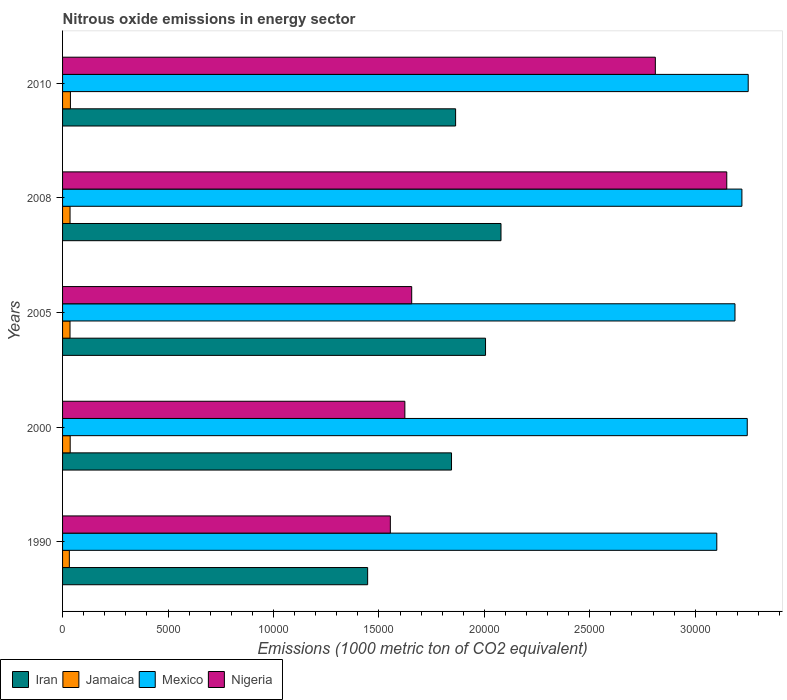How many different coloured bars are there?
Your answer should be compact. 4. In how many cases, is the number of bars for a given year not equal to the number of legend labels?
Give a very brief answer. 0. What is the amount of nitrous oxide emitted in Jamaica in 2000?
Ensure brevity in your answer.  361.6. Across all years, what is the maximum amount of nitrous oxide emitted in Nigeria?
Your answer should be compact. 3.15e+04. Across all years, what is the minimum amount of nitrous oxide emitted in Jamaica?
Give a very brief answer. 321.7. In which year was the amount of nitrous oxide emitted in Jamaica maximum?
Keep it short and to the point. 2010. What is the total amount of nitrous oxide emitted in Iran in the graph?
Give a very brief answer. 9.24e+04. What is the difference between the amount of nitrous oxide emitted in Nigeria in 2005 and that in 2008?
Provide a succinct answer. -1.49e+04. What is the difference between the amount of nitrous oxide emitted in Mexico in 1990 and the amount of nitrous oxide emitted in Nigeria in 2010?
Provide a short and direct response. 2914.6. What is the average amount of nitrous oxide emitted in Jamaica per year?
Your answer should be compact. 352.82. In the year 2008, what is the difference between the amount of nitrous oxide emitted in Mexico and amount of nitrous oxide emitted in Nigeria?
Your answer should be compact. 718.4. What is the ratio of the amount of nitrous oxide emitted in Jamaica in 2000 to that in 2010?
Your answer should be very brief. 0.97. Is the amount of nitrous oxide emitted in Jamaica in 2000 less than that in 2010?
Your response must be concise. Yes. Is the difference between the amount of nitrous oxide emitted in Mexico in 2005 and 2010 greater than the difference between the amount of nitrous oxide emitted in Nigeria in 2005 and 2010?
Give a very brief answer. Yes. What is the difference between the highest and the second highest amount of nitrous oxide emitted in Mexico?
Offer a terse response. 45.2. What is the difference between the highest and the lowest amount of nitrous oxide emitted in Mexico?
Provide a short and direct response. 1489.2. In how many years, is the amount of nitrous oxide emitted in Mexico greater than the average amount of nitrous oxide emitted in Mexico taken over all years?
Provide a succinct answer. 3. What does the 3rd bar from the top in 2008 represents?
Ensure brevity in your answer.  Jamaica. What does the 1st bar from the bottom in 2008 represents?
Your answer should be compact. Iran. What is the difference between two consecutive major ticks on the X-axis?
Offer a very short reply. 5000. Are the values on the major ticks of X-axis written in scientific E-notation?
Give a very brief answer. No. Does the graph contain grids?
Keep it short and to the point. No. How many legend labels are there?
Give a very brief answer. 4. How are the legend labels stacked?
Make the answer very short. Horizontal. What is the title of the graph?
Give a very brief answer. Nitrous oxide emissions in energy sector. Does "World" appear as one of the legend labels in the graph?
Make the answer very short. No. What is the label or title of the X-axis?
Your response must be concise. Emissions (1000 metric ton of CO2 equivalent). What is the Emissions (1000 metric ton of CO2 equivalent) of Iran in 1990?
Ensure brevity in your answer.  1.45e+04. What is the Emissions (1000 metric ton of CO2 equivalent) of Jamaica in 1990?
Make the answer very short. 321.7. What is the Emissions (1000 metric ton of CO2 equivalent) of Mexico in 1990?
Your response must be concise. 3.10e+04. What is the Emissions (1000 metric ton of CO2 equivalent) of Nigeria in 1990?
Provide a short and direct response. 1.55e+04. What is the Emissions (1000 metric ton of CO2 equivalent) in Iran in 2000?
Offer a very short reply. 1.84e+04. What is the Emissions (1000 metric ton of CO2 equivalent) of Jamaica in 2000?
Offer a terse response. 361.6. What is the Emissions (1000 metric ton of CO2 equivalent) in Mexico in 2000?
Offer a very short reply. 3.25e+04. What is the Emissions (1000 metric ton of CO2 equivalent) in Nigeria in 2000?
Ensure brevity in your answer.  1.62e+04. What is the Emissions (1000 metric ton of CO2 equivalent) in Iran in 2005?
Your response must be concise. 2.01e+04. What is the Emissions (1000 metric ton of CO2 equivalent) of Jamaica in 2005?
Your answer should be compact. 353.5. What is the Emissions (1000 metric ton of CO2 equivalent) of Mexico in 2005?
Keep it short and to the point. 3.19e+04. What is the Emissions (1000 metric ton of CO2 equivalent) in Nigeria in 2005?
Provide a short and direct response. 1.66e+04. What is the Emissions (1000 metric ton of CO2 equivalent) in Iran in 2008?
Provide a short and direct response. 2.08e+04. What is the Emissions (1000 metric ton of CO2 equivalent) of Jamaica in 2008?
Keep it short and to the point. 354.8. What is the Emissions (1000 metric ton of CO2 equivalent) in Mexico in 2008?
Offer a terse response. 3.22e+04. What is the Emissions (1000 metric ton of CO2 equivalent) in Nigeria in 2008?
Keep it short and to the point. 3.15e+04. What is the Emissions (1000 metric ton of CO2 equivalent) in Iran in 2010?
Your answer should be very brief. 1.86e+04. What is the Emissions (1000 metric ton of CO2 equivalent) in Jamaica in 2010?
Your answer should be very brief. 372.5. What is the Emissions (1000 metric ton of CO2 equivalent) in Mexico in 2010?
Offer a terse response. 3.25e+04. What is the Emissions (1000 metric ton of CO2 equivalent) in Nigeria in 2010?
Give a very brief answer. 2.81e+04. Across all years, what is the maximum Emissions (1000 metric ton of CO2 equivalent) of Iran?
Your answer should be very brief. 2.08e+04. Across all years, what is the maximum Emissions (1000 metric ton of CO2 equivalent) of Jamaica?
Make the answer very short. 372.5. Across all years, what is the maximum Emissions (1000 metric ton of CO2 equivalent) of Mexico?
Ensure brevity in your answer.  3.25e+04. Across all years, what is the maximum Emissions (1000 metric ton of CO2 equivalent) in Nigeria?
Provide a succinct answer. 3.15e+04. Across all years, what is the minimum Emissions (1000 metric ton of CO2 equivalent) of Iran?
Ensure brevity in your answer.  1.45e+04. Across all years, what is the minimum Emissions (1000 metric ton of CO2 equivalent) in Jamaica?
Give a very brief answer. 321.7. Across all years, what is the minimum Emissions (1000 metric ton of CO2 equivalent) of Mexico?
Provide a short and direct response. 3.10e+04. Across all years, what is the minimum Emissions (1000 metric ton of CO2 equivalent) in Nigeria?
Ensure brevity in your answer.  1.55e+04. What is the total Emissions (1000 metric ton of CO2 equivalent) in Iran in the graph?
Offer a very short reply. 9.24e+04. What is the total Emissions (1000 metric ton of CO2 equivalent) of Jamaica in the graph?
Offer a terse response. 1764.1. What is the total Emissions (1000 metric ton of CO2 equivalent) in Mexico in the graph?
Give a very brief answer. 1.60e+05. What is the total Emissions (1000 metric ton of CO2 equivalent) in Nigeria in the graph?
Ensure brevity in your answer.  1.08e+05. What is the difference between the Emissions (1000 metric ton of CO2 equivalent) of Iran in 1990 and that in 2000?
Provide a short and direct response. -3977.6. What is the difference between the Emissions (1000 metric ton of CO2 equivalent) in Jamaica in 1990 and that in 2000?
Your answer should be very brief. -39.9. What is the difference between the Emissions (1000 metric ton of CO2 equivalent) in Mexico in 1990 and that in 2000?
Offer a terse response. -1444. What is the difference between the Emissions (1000 metric ton of CO2 equivalent) in Nigeria in 1990 and that in 2000?
Keep it short and to the point. -688.1. What is the difference between the Emissions (1000 metric ton of CO2 equivalent) of Iran in 1990 and that in 2005?
Provide a short and direct response. -5590.3. What is the difference between the Emissions (1000 metric ton of CO2 equivalent) in Jamaica in 1990 and that in 2005?
Your answer should be compact. -31.8. What is the difference between the Emissions (1000 metric ton of CO2 equivalent) of Mexico in 1990 and that in 2005?
Give a very brief answer. -862.3. What is the difference between the Emissions (1000 metric ton of CO2 equivalent) in Nigeria in 1990 and that in 2005?
Your answer should be very brief. -1013. What is the difference between the Emissions (1000 metric ton of CO2 equivalent) of Iran in 1990 and that in 2008?
Give a very brief answer. -6323.6. What is the difference between the Emissions (1000 metric ton of CO2 equivalent) of Jamaica in 1990 and that in 2008?
Make the answer very short. -33.1. What is the difference between the Emissions (1000 metric ton of CO2 equivalent) of Mexico in 1990 and that in 2008?
Offer a terse response. -1190.5. What is the difference between the Emissions (1000 metric ton of CO2 equivalent) in Nigeria in 1990 and that in 2008?
Ensure brevity in your answer.  -1.60e+04. What is the difference between the Emissions (1000 metric ton of CO2 equivalent) in Iran in 1990 and that in 2010?
Offer a very short reply. -4171.6. What is the difference between the Emissions (1000 metric ton of CO2 equivalent) of Jamaica in 1990 and that in 2010?
Ensure brevity in your answer.  -50.8. What is the difference between the Emissions (1000 metric ton of CO2 equivalent) of Mexico in 1990 and that in 2010?
Give a very brief answer. -1489.2. What is the difference between the Emissions (1000 metric ton of CO2 equivalent) of Nigeria in 1990 and that in 2010?
Ensure brevity in your answer.  -1.26e+04. What is the difference between the Emissions (1000 metric ton of CO2 equivalent) of Iran in 2000 and that in 2005?
Ensure brevity in your answer.  -1612.7. What is the difference between the Emissions (1000 metric ton of CO2 equivalent) in Jamaica in 2000 and that in 2005?
Keep it short and to the point. 8.1. What is the difference between the Emissions (1000 metric ton of CO2 equivalent) of Mexico in 2000 and that in 2005?
Make the answer very short. 581.7. What is the difference between the Emissions (1000 metric ton of CO2 equivalent) of Nigeria in 2000 and that in 2005?
Provide a short and direct response. -324.9. What is the difference between the Emissions (1000 metric ton of CO2 equivalent) of Iran in 2000 and that in 2008?
Provide a short and direct response. -2346. What is the difference between the Emissions (1000 metric ton of CO2 equivalent) of Jamaica in 2000 and that in 2008?
Provide a succinct answer. 6.8. What is the difference between the Emissions (1000 metric ton of CO2 equivalent) of Mexico in 2000 and that in 2008?
Provide a succinct answer. 253.5. What is the difference between the Emissions (1000 metric ton of CO2 equivalent) of Nigeria in 2000 and that in 2008?
Ensure brevity in your answer.  -1.53e+04. What is the difference between the Emissions (1000 metric ton of CO2 equivalent) of Iran in 2000 and that in 2010?
Give a very brief answer. -194. What is the difference between the Emissions (1000 metric ton of CO2 equivalent) of Jamaica in 2000 and that in 2010?
Provide a succinct answer. -10.9. What is the difference between the Emissions (1000 metric ton of CO2 equivalent) of Mexico in 2000 and that in 2010?
Make the answer very short. -45.2. What is the difference between the Emissions (1000 metric ton of CO2 equivalent) of Nigeria in 2000 and that in 2010?
Offer a very short reply. -1.19e+04. What is the difference between the Emissions (1000 metric ton of CO2 equivalent) of Iran in 2005 and that in 2008?
Your response must be concise. -733.3. What is the difference between the Emissions (1000 metric ton of CO2 equivalent) in Mexico in 2005 and that in 2008?
Make the answer very short. -328.2. What is the difference between the Emissions (1000 metric ton of CO2 equivalent) of Nigeria in 2005 and that in 2008?
Keep it short and to the point. -1.49e+04. What is the difference between the Emissions (1000 metric ton of CO2 equivalent) of Iran in 2005 and that in 2010?
Provide a succinct answer. 1418.7. What is the difference between the Emissions (1000 metric ton of CO2 equivalent) in Jamaica in 2005 and that in 2010?
Your answer should be compact. -19. What is the difference between the Emissions (1000 metric ton of CO2 equivalent) of Mexico in 2005 and that in 2010?
Ensure brevity in your answer.  -626.9. What is the difference between the Emissions (1000 metric ton of CO2 equivalent) of Nigeria in 2005 and that in 2010?
Provide a succinct answer. -1.16e+04. What is the difference between the Emissions (1000 metric ton of CO2 equivalent) in Iran in 2008 and that in 2010?
Your answer should be compact. 2152. What is the difference between the Emissions (1000 metric ton of CO2 equivalent) of Jamaica in 2008 and that in 2010?
Give a very brief answer. -17.7. What is the difference between the Emissions (1000 metric ton of CO2 equivalent) in Mexico in 2008 and that in 2010?
Offer a terse response. -298.7. What is the difference between the Emissions (1000 metric ton of CO2 equivalent) of Nigeria in 2008 and that in 2010?
Make the answer very short. 3386.7. What is the difference between the Emissions (1000 metric ton of CO2 equivalent) of Iran in 1990 and the Emissions (1000 metric ton of CO2 equivalent) of Jamaica in 2000?
Give a very brief answer. 1.41e+04. What is the difference between the Emissions (1000 metric ton of CO2 equivalent) in Iran in 1990 and the Emissions (1000 metric ton of CO2 equivalent) in Mexico in 2000?
Make the answer very short. -1.80e+04. What is the difference between the Emissions (1000 metric ton of CO2 equivalent) of Iran in 1990 and the Emissions (1000 metric ton of CO2 equivalent) of Nigeria in 2000?
Your answer should be compact. -1764.9. What is the difference between the Emissions (1000 metric ton of CO2 equivalent) in Jamaica in 1990 and the Emissions (1000 metric ton of CO2 equivalent) in Mexico in 2000?
Your answer should be very brief. -3.21e+04. What is the difference between the Emissions (1000 metric ton of CO2 equivalent) of Jamaica in 1990 and the Emissions (1000 metric ton of CO2 equivalent) of Nigeria in 2000?
Your answer should be very brief. -1.59e+04. What is the difference between the Emissions (1000 metric ton of CO2 equivalent) in Mexico in 1990 and the Emissions (1000 metric ton of CO2 equivalent) in Nigeria in 2000?
Make the answer very short. 1.48e+04. What is the difference between the Emissions (1000 metric ton of CO2 equivalent) in Iran in 1990 and the Emissions (1000 metric ton of CO2 equivalent) in Jamaica in 2005?
Keep it short and to the point. 1.41e+04. What is the difference between the Emissions (1000 metric ton of CO2 equivalent) in Iran in 1990 and the Emissions (1000 metric ton of CO2 equivalent) in Mexico in 2005?
Give a very brief answer. -1.74e+04. What is the difference between the Emissions (1000 metric ton of CO2 equivalent) in Iran in 1990 and the Emissions (1000 metric ton of CO2 equivalent) in Nigeria in 2005?
Your answer should be compact. -2089.8. What is the difference between the Emissions (1000 metric ton of CO2 equivalent) of Jamaica in 1990 and the Emissions (1000 metric ton of CO2 equivalent) of Mexico in 2005?
Give a very brief answer. -3.16e+04. What is the difference between the Emissions (1000 metric ton of CO2 equivalent) in Jamaica in 1990 and the Emissions (1000 metric ton of CO2 equivalent) in Nigeria in 2005?
Offer a very short reply. -1.62e+04. What is the difference between the Emissions (1000 metric ton of CO2 equivalent) in Mexico in 1990 and the Emissions (1000 metric ton of CO2 equivalent) in Nigeria in 2005?
Ensure brevity in your answer.  1.45e+04. What is the difference between the Emissions (1000 metric ton of CO2 equivalent) in Iran in 1990 and the Emissions (1000 metric ton of CO2 equivalent) in Jamaica in 2008?
Offer a very short reply. 1.41e+04. What is the difference between the Emissions (1000 metric ton of CO2 equivalent) of Iran in 1990 and the Emissions (1000 metric ton of CO2 equivalent) of Mexico in 2008?
Your answer should be very brief. -1.77e+04. What is the difference between the Emissions (1000 metric ton of CO2 equivalent) of Iran in 1990 and the Emissions (1000 metric ton of CO2 equivalent) of Nigeria in 2008?
Make the answer very short. -1.70e+04. What is the difference between the Emissions (1000 metric ton of CO2 equivalent) in Jamaica in 1990 and the Emissions (1000 metric ton of CO2 equivalent) in Mexico in 2008?
Provide a short and direct response. -3.19e+04. What is the difference between the Emissions (1000 metric ton of CO2 equivalent) in Jamaica in 1990 and the Emissions (1000 metric ton of CO2 equivalent) in Nigeria in 2008?
Ensure brevity in your answer.  -3.12e+04. What is the difference between the Emissions (1000 metric ton of CO2 equivalent) of Mexico in 1990 and the Emissions (1000 metric ton of CO2 equivalent) of Nigeria in 2008?
Offer a very short reply. -472.1. What is the difference between the Emissions (1000 metric ton of CO2 equivalent) of Iran in 1990 and the Emissions (1000 metric ton of CO2 equivalent) of Jamaica in 2010?
Provide a succinct answer. 1.41e+04. What is the difference between the Emissions (1000 metric ton of CO2 equivalent) in Iran in 1990 and the Emissions (1000 metric ton of CO2 equivalent) in Mexico in 2010?
Your answer should be very brief. -1.80e+04. What is the difference between the Emissions (1000 metric ton of CO2 equivalent) of Iran in 1990 and the Emissions (1000 metric ton of CO2 equivalent) of Nigeria in 2010?
Your response must be concise. -1.36e+04. What is the difference between the Emissions (1000 metric ton of CO2 equivalent) of Jamaica in 1990 and the Emissions (1000 metric ton of CO2 equivalent) of Mexico in 2010?
Keep it short and to the point. -3.22e+04. What is the difference between the Emissions (1000 metric ton of CO2 equivalent) of Jamaica in 1990 and the Emissions (1000 metric ton of CO2 equivalent) of Nigeria in 2010?
Make the answer very short. -2.78e+04. What is the difference between the Emissions (1000 metric ton of CO2 equivalent) in Mexico in 1990 and the Emissions (1000 metric ton of CO2 equivalent) in Nigeria in 2010?
Provide a succinct answer. 2914.6. What is the difference between the Emissions (1000 metric ton of CO2 equivalent) of Iran in 2000 and the Emissions (1000 metric ton of CO2 equivalent) of Jamaica in 2005?
Provide a succinct answer. 1.81e+04. What is the difference between the Emissions (1000 metric ton of CO2 equivalent) in Iran in 2000 and the Emissions (1000 metric ton of CO2 equivalent) in Mexico in 2005?
Ensure brevity in your answer.  -1.34e+04. What is the difference between the Emissions (1000 metric ton of CO2 equivalent) of Iran in 2000 and the Emissions (1000 metric ton of CO2 equivalent) of Nigeria in 2005?
Offer a very short reply. 1887.8. What is the difference between the Emissions (1000 metric ton of CO2 equivalent) in Jamaica in 2000 and the Emissions (1000 metric ton of CO2 equivalent) in Mexico in 2005?
Your response must be concise. -3.15e+04. What is the difference between the Emissions (1000 metric ton of CO2 equivalent) in Jamaica in 2000 and the Emissions (1000 metric ton of CO2 equivalent) in Nigeria in 2005?
Your response must be concise. -1.62e+04. What is the difference between the Emissions (1000 metric ton of CO2 equivalent) in Mexico in 2000 and the Emissions (1000 metric ton of CO2 equivalent) in Nigeria in 2005?
Provide a short and direct response. 1.59e+04. What is the difference between the Emissions (1000 metric ton of CO2 equivalent) of Iran in 2000 and the Emissions (1000 metric ton of CO2 equivalent) of Jamaica in 2008?
Give a very brief answer. 1.81e+04. What is the difference between the Emissions (1000 metric ton of CO2 equivalent) of Iran in 2000 and the Emissions (1000 metric ton of CO2 equivalent) of Mexico in 2008?
Make the answer very short. -1.38e+04. What is the difference between the Emissions (1000 metric ton of CO2 equivalent) of Iran in 2000 and the Emissions (1000 metric ton of CO2 equivalent) of Nigeria in 2008?
Provide a succinct answer. -1.31e+04. What is the difference between the Emissions (1000 metric ton of CO2 equivalent) of Jamaica in 2000 and the Emissions (1000 metric ton of CO2 equivalent) of Mexico in 2008?
Your response must be concise. -3.19e+04. What is the difference between the Emissions (1000 metric ton of CO2 equivalent) of Jamaica in 2000 and the Emissions (1000 metric ton of CO2 equivalent) of Nigeria in 2008?
Keep it short and to the point. -3.11e+04. What is the difference between the Emissions (1000 metric ton of CO2 equivalent) in Mexico in 2000 and the Emissions (1000 metric ton of CO2 equivalent) in Nigeria in 2008?
Your answer should be compact. 971.9. What is the difference between the Emissions (1000 metric ton of CO2 equivalent) of Iran in 2000 and the Emissions (1000 metric ton of CO2 equivalent) of Jamaica in 2010?
Your answer should be very brief. 1.81e+04. What is the difference between the Emissions (1000 metric ton of CO2 equivalent) in Iran in 2000 and the Emissions (1000 metric ton of CO2 equivalent) in Mexico in 2010?
Keep it short and to the point. -1.41e+04. What is the difference between the Emissions (1000 metric ton of CO2 equivalent) of Iran in 2000 and the Emissions (1000 metric ton of CO2 equivalent) of Nigeria in 2010?
Your answer should be very brief. -9664.5. What is the difference between the Emissions (1000 metric ton of CO2 equivalent) of Jamaica in 2000 and the Emissions (1000 metric ton of CO2 equivalent) of Mexico in 2010?
Offer a terse response. -3.22e+04. What is the difference between the Emissions (1000 metric ton of CO2 equivalent) in Jamaica in 2000 and the Emissions (1000 metric ton of CO2 equivalent) in Nigeria in 2010?
Give a very brief answer. -2.77e+04. What is the difference between the Emissions (1000 metric ton of CO2 equivalent) of Mexico in 2000 and the Emissions (1000 metric ton of CO2 equivalent) of Nigeria in 2010?
Keep it short and to the point. 4358.6. What is the difference between the Emissions (1000 metric ton of CO2 equivalent) of Iran in 2005 and the Emissions (1000 metric ton of CO2 equivalent) of Jamaica in 2008?
Provide a short and direct response. 1.97e+04. What is the difference between the Emissions (1000 metric ton of CO2 equivalent) in Iran in 2005 and the Emissions (1000 metric ton of CO2 equivalent) in Mexico in 2008?
Offer a very short reply. -1.22e+04. What is the difference between the Emissions (1000 metric ton of CO2 equivalent) in Iran in 2005 and the Emissions (1000 metric ton of CO2 equivalent) in Nigeria in 2008?
Ensure brevity in your answer.  -1.14e+04. What is the difference between the Emissions (1000 metric ton of CO2 equivalent) of Jamaica in 2005 and the Emissions (1000 metric ton of CO2 equivalent) of Mexico in 2008?
Give a very brief answer. -3.19e+04. What is the difference between the Emissions (1000 metric ton of CO2 equivalent) of Jamaica in 2005 and the Emissions (1000 metric ton of CO2 equivalent) of Nigeria in 2008?
Offer a very short reply. -3.11e+04. What is the difference between the Emissions (1000 metric ton of CO2 equivalent) of Mexico in 2005 and the Emissions (1000 metric ton of CO2 equivalent) of Nigeria in 2008?
Your answer should be compact. 390.2. What is the difference between the Emissions (1000 metric ton of CO2 equivalent) in Iran in 2005 and the Emissions (1000 metric ton of CO2 equivalent) in Jamaica in 2010?
Offer a very short reply. 1.97e+04. What is the difference between the Emissions (1000 metric ton of CO2 equivalent) of Iran in 2005 and the Emissions (1000 metric ton of CO2 equivalent) of Mexico in 2010?
Offer a very short reply. -1.25e+04. What is the difference between the Emissions (1000 metric ton of CO2 equivalent) of Iran in 2005 and the Emissions (1000 metric ton of CO2 equivalent) of Nigeria in 2010?
Make the answer very short. -8051.8. What is the difference between the Emissions (1000 metric ton of CO2 equivalent) of Jamaica in 2005 and the Emissions (1000 metric ton of CO2 equivalent) of Mexico in 2010?
Make the answer very short. -3.22e+04. What is the difference between the Emissions (1000 metric ton of CO2 equivalent) of Jamaica in 2005 and the Emissions (1000 metric ton of CO2 equivalent) of Nigeria in 2010?
Provide a succinct answer. -2.78e+04. What is the difference between the Emissions (1000 metric ton of CO2 equivalent) of Mexico in 2005 and the Emissions (1000 metric ton of CO2 equivalent) of Nigeria in 2010?
Offer a very short reply. 3776.9. What is the difference between the Emissions (1000 metric ton of CO2 equivalent) of Iran in 2008 and the Emissions (1000 metric ton of CO2 equivalent) of Jamaica in 2010?
Keep it short and to the point. 2.04e+04. What is the difference between the Emissions (1000 metric ton of CO2 equivalent) in Iran in 2008 and the Emissions (1000 metric ton of CO2 equivalent) in Mexico in 2010?
Offer a very short reply. -1.17e+04. What is the difference between the Emissions (1000 metric ton of CO2 equivalent) of Iran in 2008 and the Emissions (1000 metric ton of CO2 equivalent) of Nigeria in 2010?
Your answer should be very brief. -7318.5. What is the difference between the Emissions (1000 metric ton of CO2 equivalent) of Jamaica in 2008 and the Emissions (1000 metric ton of CO2 equivalent) of Mexico in 2010?
Provide a short and direct response. -3.22e+04. What is the difference between the Emissions (1000 metric ton of CO2 equivalent) in Jamaica in 2008 and the Emissions (1000 metric ton of CO2 equivalent) in Nigeria in 2010?
Offer a terse response. -2.78e+04. What is the difference between the Emissions (1000 metric ton of CO2 equivalent) in Mexico in 2008 and the Emissions (1000 metric ton of CO2 equivalent) in Nigeria in 2010?
Your response must be concise. 4105.1. What is the average Emissions (1000 metric ton of CO2 equivalent) of Iran per year?
Your answer should be very brief. 1.85e+04. What is the average Emissions (1000 metric ton of CO2 equivalent) of Jamaica per year?
Your answer should be very brief. 352.82. What is the average Emissions (1000 metric ton of CO2 equivalent) of Mexico per year?
Your answer should be very brief. 3.20e+04. What is the average Emissions (1000 metric ton of CO2 equivalent) in Nigeria per year?
Give a very brief answer. 2.16e+04. In the year 1990, what is the difference between the Emissions (1000 metric ton of CO2 equivalent) of Iran and Emissions (1000 metric ton of CO2 equivalent) of Jamaica?
Provide a short and direct response. 1.41e+04. In the year 1990, what is the difference between the Emissions (1000 metric ton of CO2 equivalent) of Iran and Emissions (1000 metric ton of CO2 equivalent) of Mexico?
Make the answer very short. -1.66e+04. In the year 1990, what is the difference between the Emissions (1000 metric ton of CO2 equivalent) in Iran and Emissions (1000 metric ton of CO2 equivalent) in Nigeria?
Make the answer very short. -1076.8. In the year 1990, what is the difference between the Emissions (1000 metric ton of CO2 equivalent) in Jamaica and Emissions (1000 metric ton of CO2 equivalent) in Mexico?
Make the answer very short. -3.07e+04. In the year 1990, what is the difference between the Emissions (1000 metric ton of CO2 equivalent) of Jamaica and Emissions (1000 metric ton of CO2 equivalent) of Nigeria?
Offer a terse response. -1.52e+04. In the year 1990, what is the difference between the Emissions (1000 metric ton of CO2 equivalent) in Mexico and Emissions (1000 metric ton of CO2 equivalent) in Nigeria?
Your response must be concise. 1.55e+04. In the year 2000, what is the difference between the Emissions (1000 metric ton of CO2 equivalent) of Iran and Emissions (1000 metric ton of CO2 equivalent) of Jamaica?
Make the answer very short. 1.81e+04. In the year 2000, what is the difference between the Emissions (1000 metric ton of CO2 equivalent) of Iran and Emissions (1000 metric ton of CO2 equivalent) of Mexico?
Ensure brevity in your answer.  -1.40e+04. In the year 2000, what is the difference between the Emissions (1000 metric ton of CO2 equivalent) of Iran and Emissions (1000 metric ton of CO2 equivalent) of Nigeria?
Make the answer very short. 2212.7. In the year 2000, what is the difference between the Emissions (1000 metric ton of CO2 equivalent) in Jamaica and Emissions (1000 metric ton of CO2 equivalent) in Mexico?
Your answer should be compact. -3.21e+04. In the year 2000, what is the difference between the Emissions (1000 metric ton of CO2 equivalent) in Jamaica and Emissions (1000 metric ton of CO2 equivalent) in Nigeria?
Provide a short and direct response. -1.59e+04. In the year 2000, what is the difference between the Emissions (1000 metric ton of CO2 equivalent) of Mexico and Emissions (1000 metric ton of CO2 equivalent) of Nigeria?
Make the answer very short. 1.62e+04. In the year 2005, what is the difference between the Emissions (1000 metric ton of CO2 equivalent) in Iran and Emissions (1000 metric ton of CO2 equivalent) in Jamaica?
Offer a very short reply. 1.97e+04. In the year 2005, what is the difference between the Emissions (1000 metric ton of CO2 equivalent) in Iran and Emissions (1000 metric ton of CO2 equivalent) in Mexico?
Keep it short and to the point. -1.18e+04. In the year 2005, what is the difference between the Emissions (1000 metric ton of CO2 equivalent) of Iran and Emissions (1000 metric ton of CO2 equivalent) of Nigeria?
Offer a very short reply. 3500.5. In the year 2005, what is the difference between the Emissions (1000 metric ton of CO2 equivalent) of Jamaica and Emissions (1000 metric ton of CO2 equivalent) of Mexico?
Ensure brevity in your answer.  -3.15e+04. In the year 2005, what is the difference between the Emissions (1000 metric ton of CO2 equivalent) of Jamaica and Emissions (1000 metric ton of CO2 equivalent) of Nigeria?
Make the answer very short. -1.62e+04. In the year 2005, what is the difference between the Emissions (1000 metric ton of CO2 equivalent) of Mexico and Emissions (1000 metric ton of CO2 equivalent) of Nigeria?
Provide a short and direct response. 1.53e+04. In the year 2008, what is the difference between the Emissions (1000 metric ton of CO2 equivalent) in Iran and Emissions (1000 metric ton of CO2 equivalent) in Jamaica?
Give a very brief answer. 2.04e+04. In the year 2008, what is the difference between the Emissions (1000 metric ton of CO2 equivalent) in Iran and Emissions (1000 metric ton of CO2 equivalent) in Mexico?
Your response must be concise. -1.14e+04. In the year 2008, what is the difference between the Emissions (1000 metric ton of CO2 equivalent) of Iran and Emissions (1000 metric ton of CO2 equivalent) of Nigeria?
Make the answer very short. -1.07e+04. In the year 2008, what is the difference between the Emissions (1000 metric ton of CO2 equivalent) of Jamaica and Emissions (1000 metric ton of CO2 equivalent) of Mexico?
Provide a succinct answer. -3.19e+04. In the year 2008, what is the difference between the Emissions (1000 metric ton of CO2 equivalent) of Jamaica and Emissions (1000 metric ton of CO2 equivalent) of Nigeria?
Offer a very short reply. -3.11e+04. In the year 2008, what is the difference between the Emissions (1000 metric ton of CO2 equivalent) in Mexico and Emissions (1000 metric ton of CO2 equivalent) in Nigeria?
Your response must be concise. 718.4. In the year 2010, what is the difference between the Emissions (1000 metric ton of CO2 equivalent) of Iran and Emissions (1000 metric ton of CO2 equivalent) of Jamaica?
Your response must be concise. 1.83e+04. In the year 2010, what is the difference between the Emissions (1000 metric ton of CO2 equivalent) in Iran and Emissions (1000 metric ton of CO2 equivalent) in Mexico?
Your answer should be compact. -1.39e+04. In the year 2010, what is the difference between the Emissions (1000 metric ton of CO2 equivalent) in Iran and Emissions (1000 metric ton of CO2 equivalent) in Nigeria?
Your response must be concise. -9470.5. In the year 2010, what is the difference between the Emissions (1000 metric ton of CO2 equivalent) in Jamaica and Emissions (1000 metric ton of CO2 equivalent) in Mexico?
Provide a succinct answer. -3.21e+04. In the year 2010, what is the difference between the Emissions (1000 metric ton of CO2 equivalent) in Jamaica and Emissions (1000 metric ton of CO2 equivalent) in Nigeria?
Ensure brevity in your answer.  -2.77e+04. In the year 2010, what is the difference between the Emissions (1000 metric ton of CO2 equivalent) in Mexico and Emissions (1000 metric ton of CO2 equivalent) in Nigeria?
Your answer should be compact. 4403.8. What is the ratio of the Emissions (1000 metric ton of CO2 equivalent) of Iran in 1990 to that in 2000?
Give a very brief answer. 0.78. What is the ratio of the Emissions (1000 metric ton of CO2 equivalent) of Jamaica in 1990 to that in 2000?
Keep it short and to the point. 0.89. What is the ratio of the Emissions (1000 metric ton of CO2 equivalent) of Mexico in 1990 to that in 2000?
Give a very brief answer. 0.96. What is the ratio of the Emissions (1000 metric ton of CO2 equivalent) in Nigeria in 1990 to that in 2000?
Give a very brief answer. 0.96. What is the ratio of the Emissions (1000 metric ton of CO2 equivalent) in Iran in 1990 to that in 2005?
Offer a very short reply. 0.72. What is the ratio of the Emissions (1000 metric ton of CO2 equivalent) in Jamaica in 1990 to that in 2005?
Keep it short and to the point. 0.91. What is the ratio of the Emissions (1000 metric ton of CO2 equivalent) of Nigeria in 1990 to that in 2005?
Give a very brief answer. 0.94. What is the ratio of the Emissions (1000 metric ton of CO2 equivalent) in Iran in 1990 to that in 2008?
Ensure brevity in your answer.  0.7. What is the ratio of the Emissions (1000 metric ton of CO2 equivalent) in Jamaica in 1990 to that in 2008?
Offer a terse response. 0.91. What is the ratio of the Emissions (1000 metric ton of CO2 equivalent) in Mexico in 1990 to that in 2008?
Provide a succinct answer. 0.96. What is the ratio of the Emissions (1000 metric ton of CO2 equivalent) of Nigeria in 1990 to that in 2008?
Offer a terse response. 0.49. What is the ratio of the Emissions (1000 metric ton of CO2 equivalent) of Iran in 1990 to that in 2010?
Provide a short and direct response. 0.78. What is the ratio of the Emissions (1000 metric ton of CO2 equivalent) of Jamaica in 1990 to that in 2010?
Offer a very short reply. 0.86. What is the ratio of the Emissions (1000 metric ton of CO2 equivalent) of Mexico in 1990 to that in 2010?
Make the answer very short. 0.95. What is the ratio of the Emissions (1000 metric ton of CO2 equivalent) in Nigeria in 1990 to that in 2010?
Your answer should be compact. 0.55. What is the ratio of the Emissions (1000 metric ton of CO2 equivalent) in Iran in 2000 to that in 2005?
Offer a terse response. 0.92. What is the ratio of the Emissions (1000 metric ton of CO2 equivalent) of Jamaica in 2000 to that in 2005?
Make the answer very short. 1.02. What is the ratio of the Emissions (1000 metric ton of CO2 equivalent) of Mexico in 2000 to that in 2005?
Your response must be concise. 1.02. What is the ratio of the Emissions (1000 metric ton of CO2 equivalent) of Nigeria in 2000 to that in 2005?
Make the answer very short. 0.98. What is the ratio of the Emissions (1000 metric ton of CO2 equivalent) of Iran in 2000 to that in 2008?
Your answer should be very brief. 0.89. What is the ratio of the Emissions (1000 metric ton of CO2 equivalent) of Jamaica in 2000 to that in 2008?
Make the answer very short. 1.02. What is the ratio of the Emissions (1000 metric ton of CO2 equivalent) of Mexico in 2000 to that in 2008?
Your answer should be compact. 1.01. What is the ratio of the Emissions (1000 metric ton of CO2 equivalent) of Nigeria in 2000 to that in 2008?
Your answer should be very brief. 0.52. What is the ratio of the Emissions (1000 metric ton of CO2 equivalent) of Iran in 2000 to that in 2010?
Offer a terse response. 0.99. What is the ratio of the Emissions (1000 metric ton of CO2 equivalent) in Jamaica in 2000 to that in 2010?
Keep it short and to the point. 0.97. What is the ratio of the Emissions (1000 metric ton of CO2 equivalent) of Nigeria in 2000 to that in 2010?
Your answer should be very brief. 0.58. What is the ratio of the Emissions (1000 metric ton of CO2 equivalent) of Iran in 2005 to that in 2008?
Offer a very short reply. 0.96. What is the ratio of the Emissions (1000 metric ton of CO2 equivalent) of Nigeria in 2005 to that in 2008?
Make the answer very short. 0.53. What is the ratio of the Emissions (1000 metric ton of CO2 equivalent) of Iran in 2005 to that in 2010?
Your response must be concise. 1.08. What is the ratio of the Emissions (1000 metric ton of CO2 equivalent) in Jamaica in 2005 to that in 2010?
Your answer should be compact. 0.95. What is the ratio of the Emissions (1000 metric ton of CO2 equivalent) in Mexico in 2005 to that in 2010?
Provide a succinct answer. 0.98. What is the ratio of the Emissions (1000 metric ton of CO2 equivalent) of Nigeria in 2005 to that in 2010?
Give a very brief answer. 0.59. What is the ratio of the Emissions (1000 metric ton of CO2 equivalent) in Iran in 2008 to that in 2010?
Your response must be concise. 1.12. What is the ratio of the Emissions (1000 metric ton of CO2 equivalent) in Jamaica in 2008 to that in 2010?
Make the answer very short. 0.95. What is the ratio of the Emissions (1000 metric ton of CO2 equivalent) in Mexico in 2008 to that in 2010?
Keep it short and to the point. 0.99. What is the ratio of the Emissions (1000 metric ton of CO2 equivalent) in Nigeria in 2008 to that in 2010?
Your answer should be compact. 1.12. What is the difference between the highest and the second highest Emissions (1000 metric ton of CO2 equivalent) in Iran?
Ensure brevity in your answer.  733.3. What is the difference between the highest and the second highest Emissions (1000 metric ton of CO2 equivalent) in Jamaica?
Your answer should be very brief. 10.9. What is the difference between the highest and the second highest Emissions (1000 metric ton of CO2 equivalent) in Mexico?
Your answer should be compact. 45.2. What is the difference between the highest and the second highest Emissions (1000 metric ton of CO2 equivalent) of Nigeria?
Make the answer very short. 3386.7. What is the difference between the highest and the lowest Emissions (1000 metric ton of CO2 equivalent) of Iran?
Keep it short and to the point. 6323.6. What is the difference between the highest and the lowest Emissions (1000 metric ton of CO2 equivalent) in Jamaica?
Offer a very short reply. 50.8. What is the difference between the highest and the lowest Emissions (1000 metric ton of CO2 equivalent) of Mexico?
Give a very brief answer. 1489.2. What is the difference between the highest and the lowest Emissions (1000 metric ton of CO2 equivalent) in Nigeria?
Give a very brief answer. 1.60e+04. 